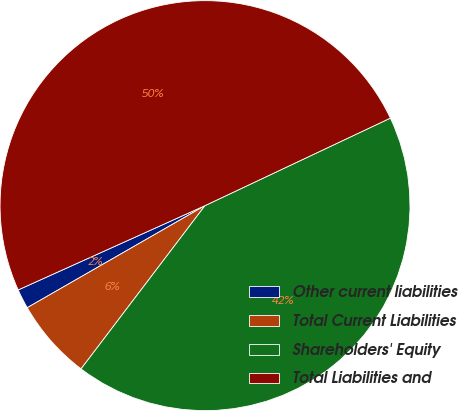<chart> <loc_0><loc_0><loc_500><loc_500><pie_chart><fcel>Other current liabilities<fcel>Total Current Liabilities<fcel>Shareholders' Equity<fcel>Total Liabilities and<nl><fcel>1.55%<fcel>6.37%<fcel>42.36%<fcel>49.73%<nl></chart> 